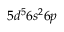Convert formula to latex. <formula><loc_0><loc_0><loc_500><loc_500>5 d ^ { 5 } 6 s ^ { 2 } 6 p</formula> 